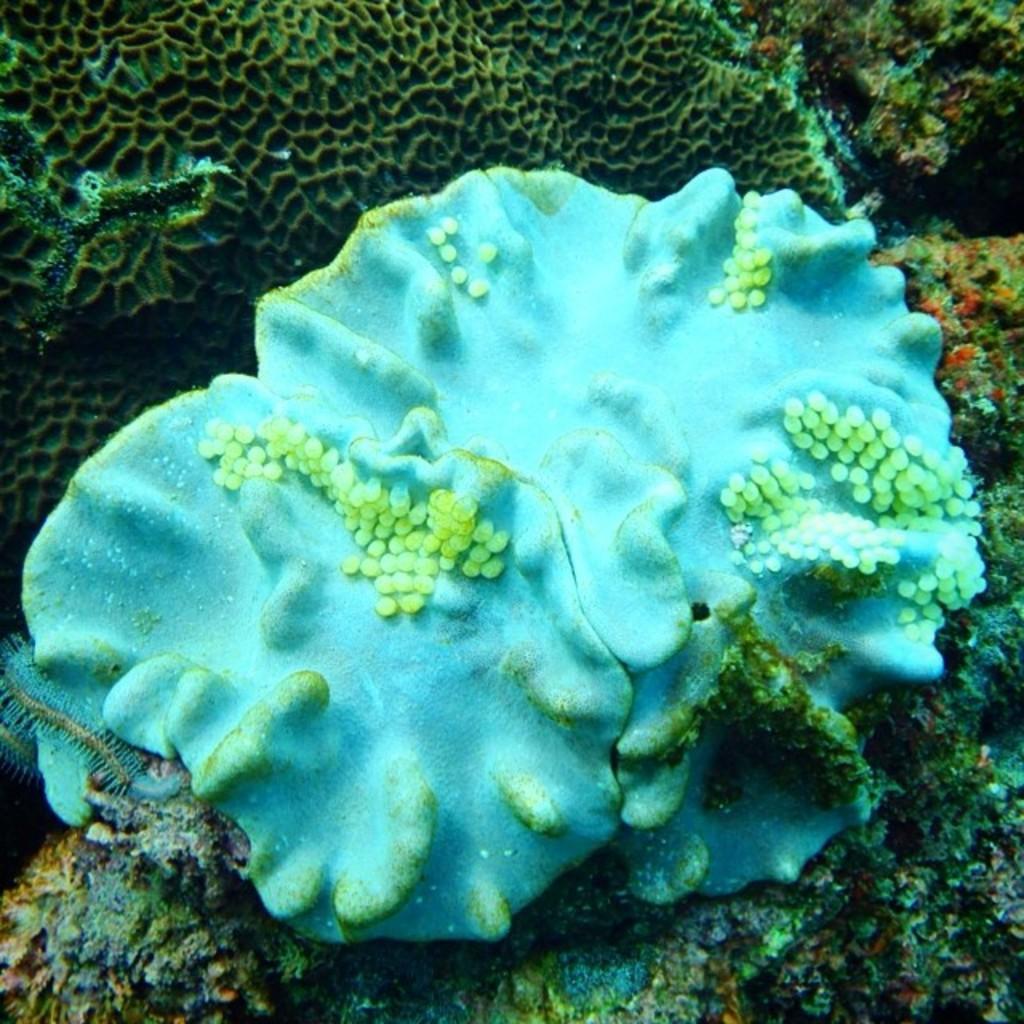Could you give a brief overview of what you see in this image? In this image we can see some underwater plants. 